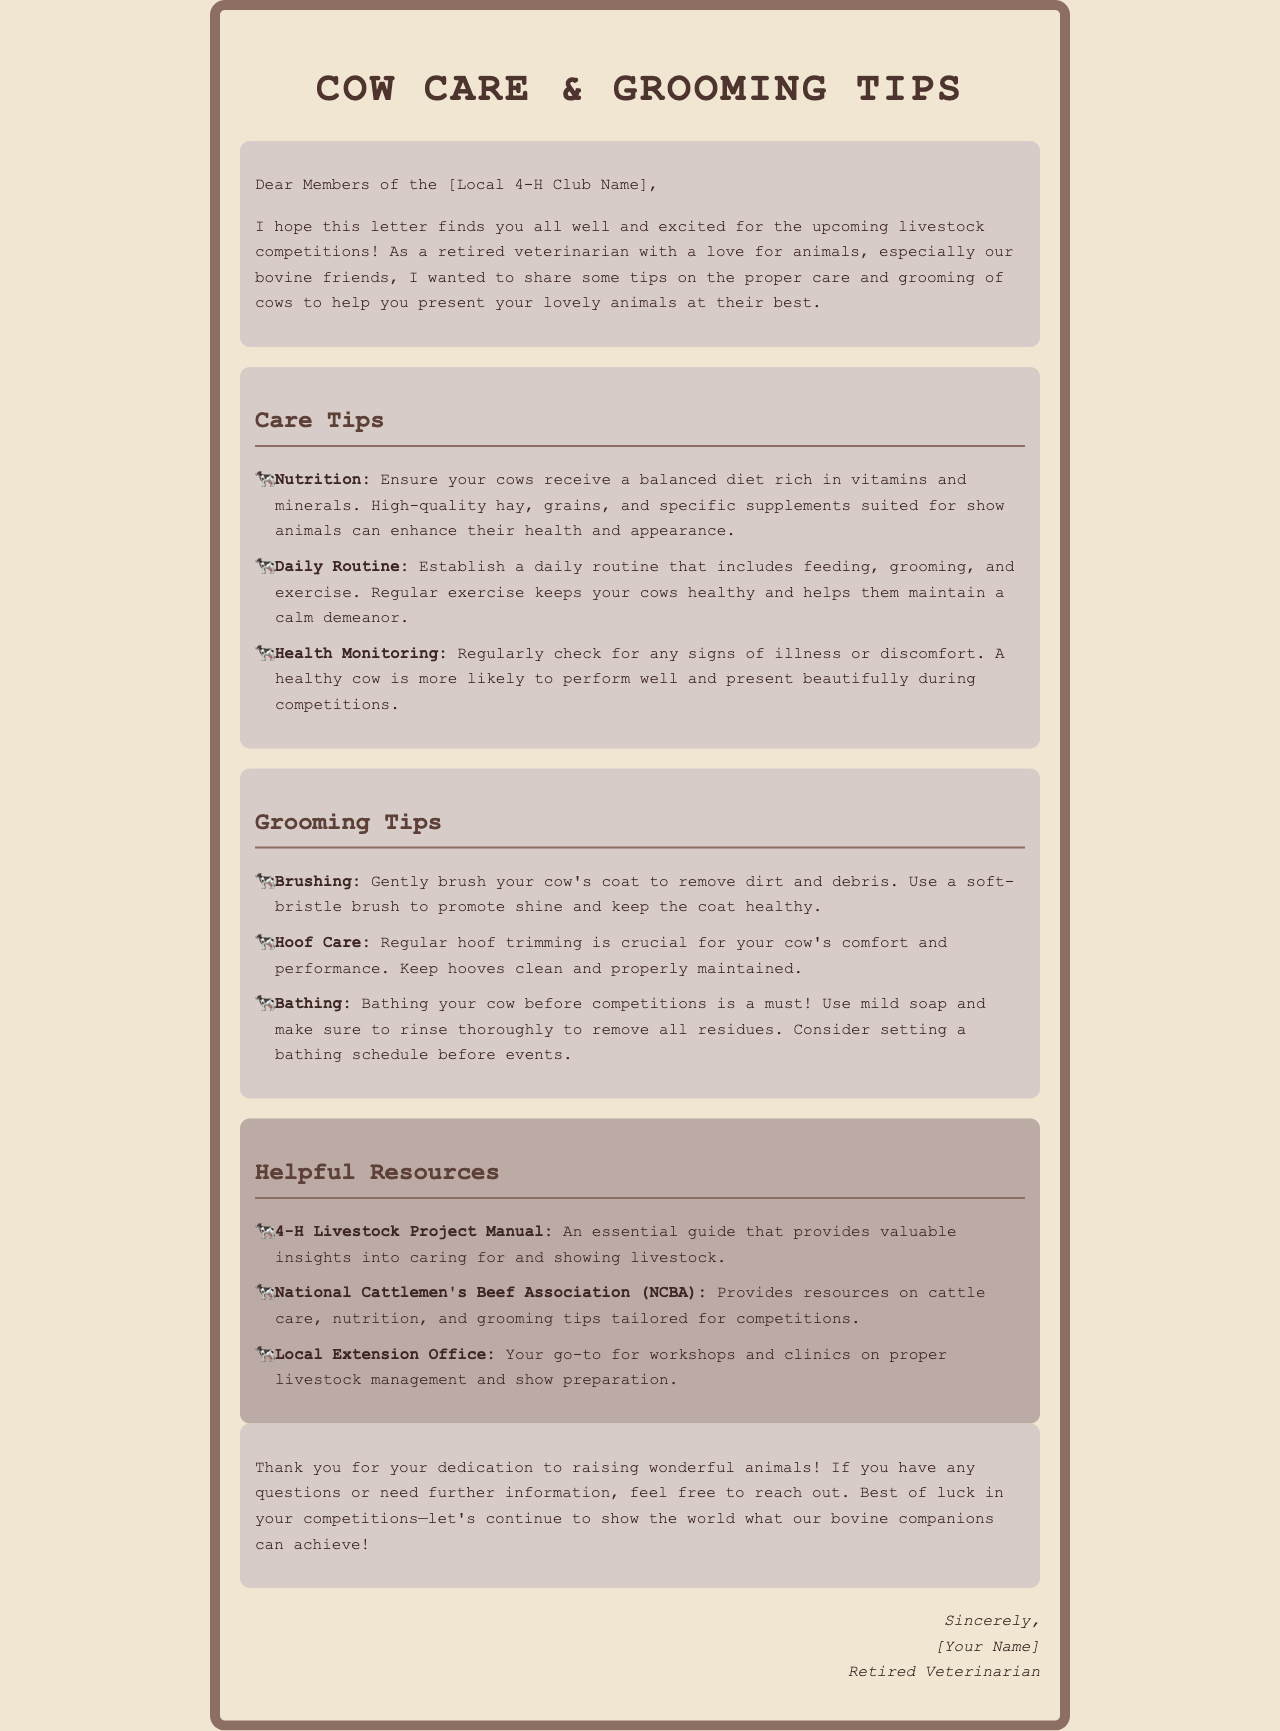What is the main purpose of the letter? The letter aims to share tips on the proper care and grooming of cows for competitions with the 4-H Club members.
Answer: Share tips on proper care and grooming of cows Who is the author of the letter? The author is identified as a retired veterinarian who shares expertise about animal care.
Answer: Retired Veterinarian What are two key aspects of cow care mentioned? The document highlights nutrition and health monitoring as key aspects of cow care.
Answer: Nutrition and health monitoring What should be used for brushing cows? The letter specifies that a soft-bristle brush should be used for brushing cows.
Answer: Soft-bristle brush Name a resource provided for 4-H Club members. One of the listed resources is the 4-H Livestock Project Manual.
Answer: 4-H Livestock Project Manual What is one technique suggested for hoof care? The letter advises that regular hoof trimming is crucial for a cow’s comfort.
Answer: Regular hoof trimming How should cows be bathed before competitions? The letter recommends using mild soap and rinsing thoroughly to remove all residues.
Answer: Use mild soap and rinse thoroughly What is emphasized about daily routines for cows? Establishing a daily routine including feeding, grooming, and exercise is emphasized in the letter.
Answer: Feeding, grooming, and exercise What is the tone of the letter? The tone of the letter is friendly and supportive towards 4-H Club members.
Answer: Friendly and supportive 